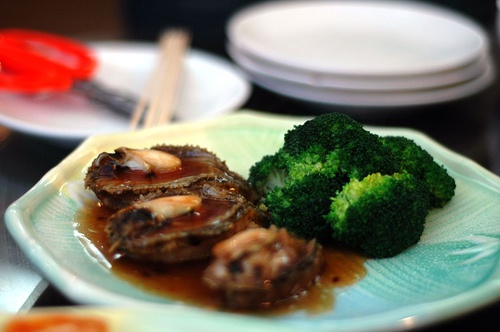Describe the objects in this image and their specific colors. I can see broccoli in black, darkgreen, and green tones, dining table in black, gray, white, and darkgray tones, and scissors in black, red, gray, salmon, and brown tones in this image. 